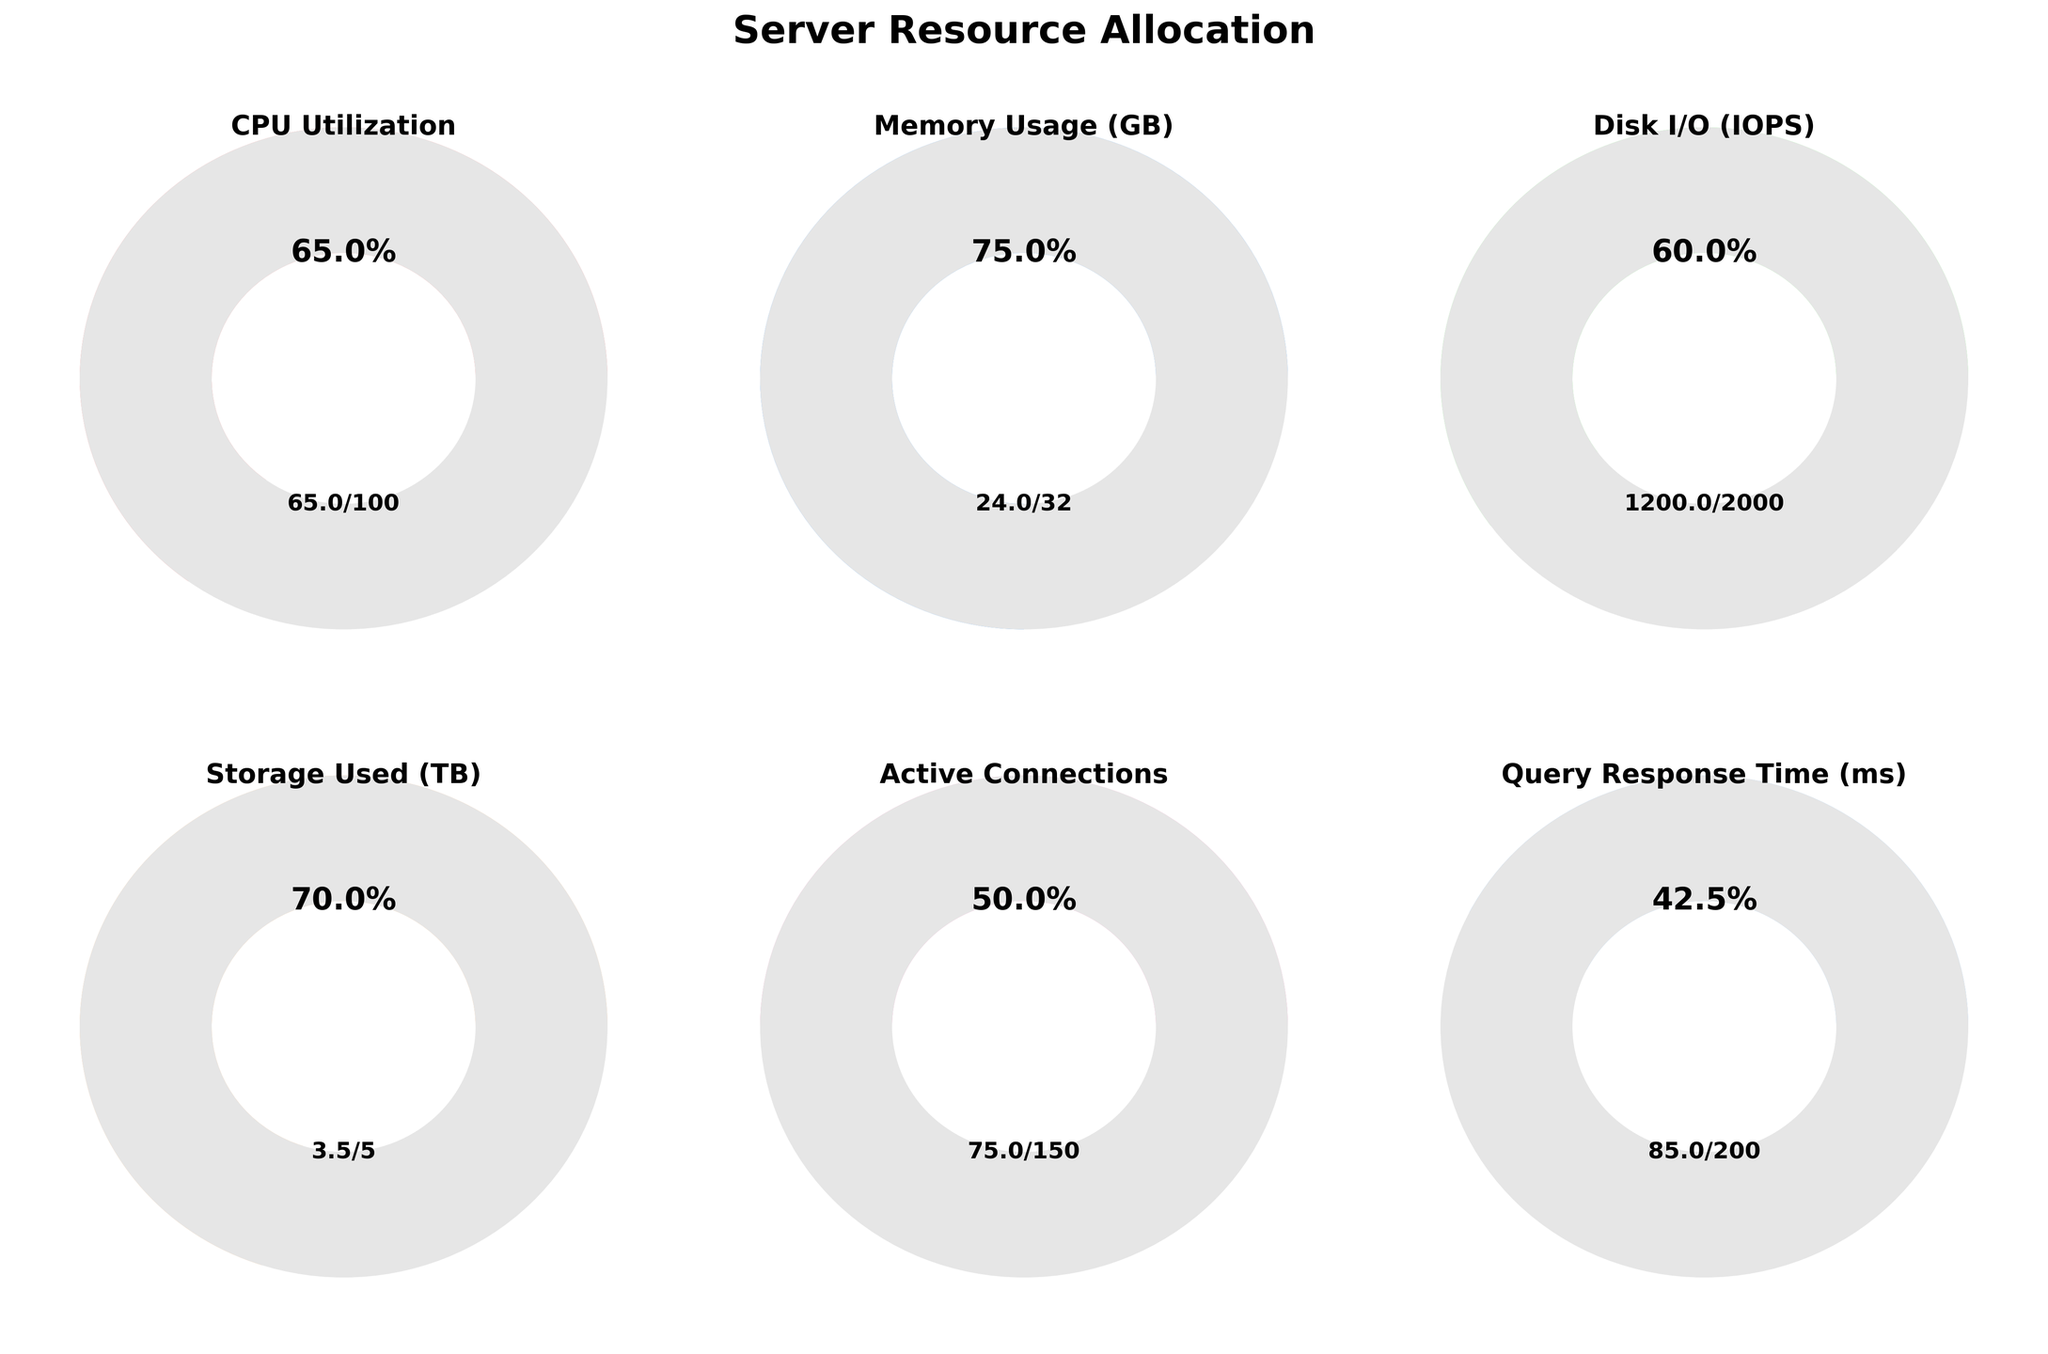What's the highest resource usage percentage? The resource with the highest percentage is Disk I/O, which has a usage of 1200 and a maximum of 2000. This results in a percentage of 1200/2000 = 60%.
Answer: Disk I/O Which resource shows the lowest percentage of usage? The resource with the lowest usage percentage is Storage Used, 3.5 out of 5 TB, equating to a percentage of 3.5/5 = 70%.
Answer: Storage Used How much higher is the CPU utilization percentage compared to the percentage of active connections? The CPU utilization percentage is 65% (65 out of 100) and the active connections percentage is 50% (75 out of 150). The difference is 65% - 50% = 15%.
Answer: 15% What is the combined value of the two lowest resource usages? The two lowest usage values are CPU Utilization (65) and Query Response Time (85). Therefore, the combined value is 65 + 85 = 150.
Answer: 150 Which usage value is closest to its maximum value in absolute terms? The closest usage value to its maximum in absolute terms is Memory Usage, which is 24 GB out of a max of 32 GB, leaving only 8 GB remaining.
Answer: Memory Usage What is the average percentage usage of all resources? Calculating individual percentages: CPU: 65%, Memory: 75%, Disk I/O: 60%, Storage Used: 70%, Active Connections: 50%, Query Response Time: 42.5%. The average percentage is (65 + 75 + 60 + 70 + 50 + 42.5) / 6 ≈ 60.42%.
Answer: ≈ 60.42% Is the percentage of memory usage greater than 70%? The memory usage is 24 GB out of 32 GB, which results in a percentage of 24/32 = 75%. Thus, yes, it is greater than 70%.
Answer: Yes How many resources have been utilized more than 50% capacity? The resources utilized more than 50% capacity are CPU Utilization, Memory Usage, Disk I/O, and Storage Used. This totals to 4 resources.
Answer: 4 